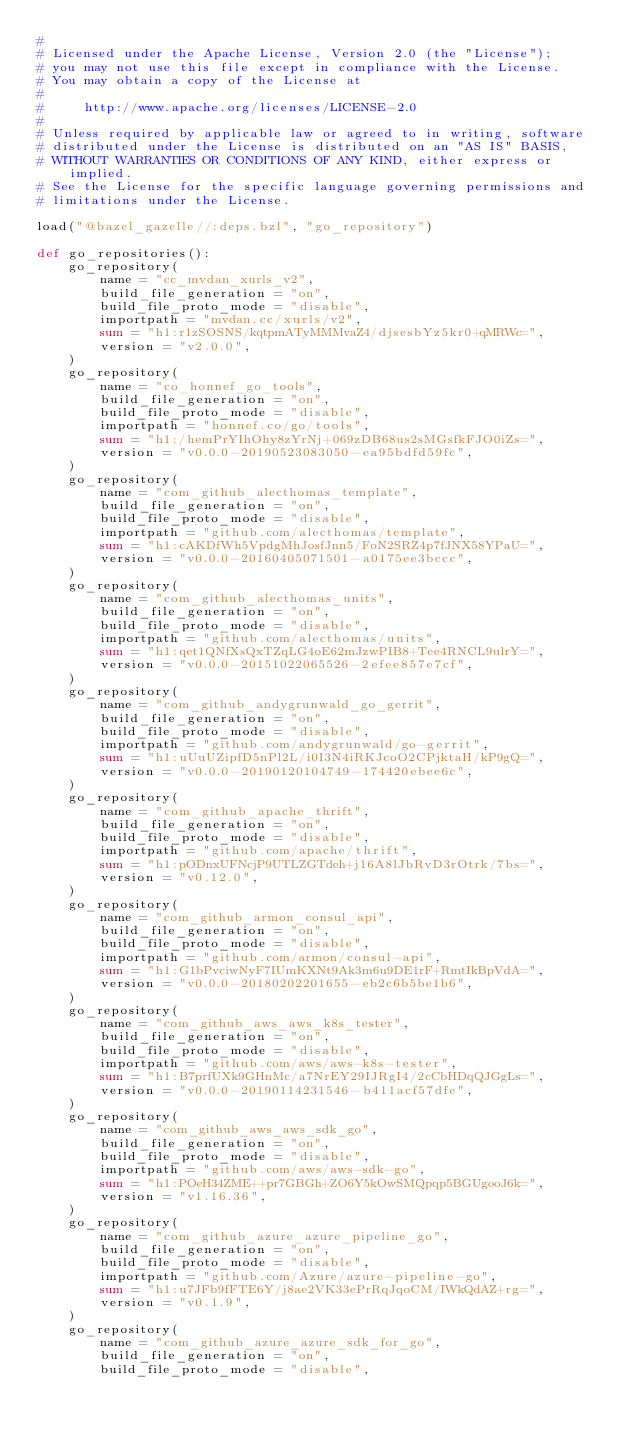Convert code to text. <code><loc_0><loc_0><loc_500><loc_500><_Python_>#
# Licensed under the Apache License, Version 2.0 (the "License");
# you may not use this file except in compliance with the License.
# You may obtain a copy of the License at
#
#     http://www.apache.org/licenses/LICENSE-2.0
#
# Unless required by applicable law or agreed to in writing, software
# distributed under the License is distributed on an "AS IS" BASIS,
# WITHOUT WARRANTIES OR CONDITIONS OF ANY KIND, either express or implied.
# See the License for the specific language governing permissions and
# limitations under the License.

load("@bazel_gazelle//:deps.bzl", "go_repository")

def go_repositories():
    go_repository(
        name = "cc_mvdan_xurls_v2",
        build_file_generation = "on",
        build_file_proto_mode = "disable",
        importpath = "mvdan.cc/xurls/v2",
        sum = "h1:r1zSOSNS/kqtpmATyMMMvaZ4/djsesbYz5kr0+qMRWc=",
        version = "v2.0.0",
    )
    go_repository(
        name = "co_honnef_go_tools",
        build_file_generation = "on",
        build_file_proto_mode = "disable",
        importpath = "honnef.co/go/tools",
        sum = "h1:/hemPrYIhOhy8zYrNj+069zDB68us2sMGsfkFJO0iZs=",
        version = "v0.0.0-20190523083050-ea95bdfd59fc",
    )
    go_repository(
        name = "com_github_alecthomas_template",
        build_file_generation = "on",
        build_file_proto_mode = "disable",
        importpath = "github.com/alecthomas/template",
        sum = "h1:cAKDfWh5VpdgMhJosfJnn5/FoN2SRZ4p7fJNX58YPaU=",
        version = "v0.0.0-20160405071501-a0175ee3bccc",
    )
    go_repository(
        name = "com_github_alecthomas_units",
        build_file_generation = "on",
        build_file_proto_mode = "disable",
        importpath = "github.com/alecthomas/units",
        sum = "h1:qet1QNfXsQxTZqLG4oE62mJzwPIB8+Tee4RNCL9ulrY=",
        version = "v0.0.0-20151022065526-2efee857e7cf",
    )
    go_repository(
        name = "com_github_andygrunwald_go_gerrit",
        build_file_generation = "on",
        build_file_proto_mode = "disable",
        importpath = "github.com/andygrunwald/go-gerrit",
        sum = "h1:uUuUZipfD5nPl2L/i0I3N4iRKJcoO2CPjktaH/kP9gQ=",
        version = "v0.0.0-20190120104749-174420ebee6c",
    )
    go_repository(
        name = "com_github_apache_thrift",
        build_file_generation = "on",
        build_file_proto_mode = "disable",
        importpath = "github.com/apache/thrift",
        sum = "h1:pODnxUFNcjP9UTLZGTdeh+j16A8lJbRvD3rOtrk/7bs=",
        version = "v0.12.0",
    )
    go_repository(
        name = "com_github_armon_consul_api",
        build_file_generation = "on",
        build_file_proto_mode = "disable",
        importpath = "github.com/armon/consul-api",
        sum = "h1:G1bPvciwNyF7IUmKXNt9Ak3m6u9DE1rF+RmtIkBpVdA=",
        version = "v0.0.0-20180202201655-eb2c6b5be1b6",
    )
    go_repository(
        name = "com_github_aws_aws_k8s_tester",
        build_file_generation = "on",
        build_file_proto_mode = "disable",
        importpath = "github.com/aws/aws-k8s-tester",
        sum = "h1:B7prfUXk9GHnMc/a7NrEY29IJRgI4/2cCbHDqQJGgLs=",
        version = "v0.0.0-20190114231546-b411acf57dfe",
    )
    go_repository(
        name = "com_github_aws_aws_sdk_go",
        build_file_generation = "on",
        build_file_proto_mode = "disable",
        importpath = "github.com/aws/aws-sdk-go",
        sum = "h1:POeH34ZME++pr7GBGh+ZO6Y5kOwSMQpqp5BGUgooJ6k=",
        version = "v1.16.36",
    )
    go_repository(
        name = "com_github_azure_azure_pipeline_go",
        build_file_generation = "on",
        build_file_proto_mode = "disable",
        importpath = "github.com/Azure/azure-pipeline-go",
        sum = "h1:u7JFb9fFTE6Y/j8ae2VK33ePrRqJqoCM/IWkQdAZ+rg=",
        version = "v0.1.9",
    )
    go_repository(
        name = "com_github_azure_azure_sdk_for_go",
        build_file_generation = "on",
        build_file_proto_mode = "disable",</code> 